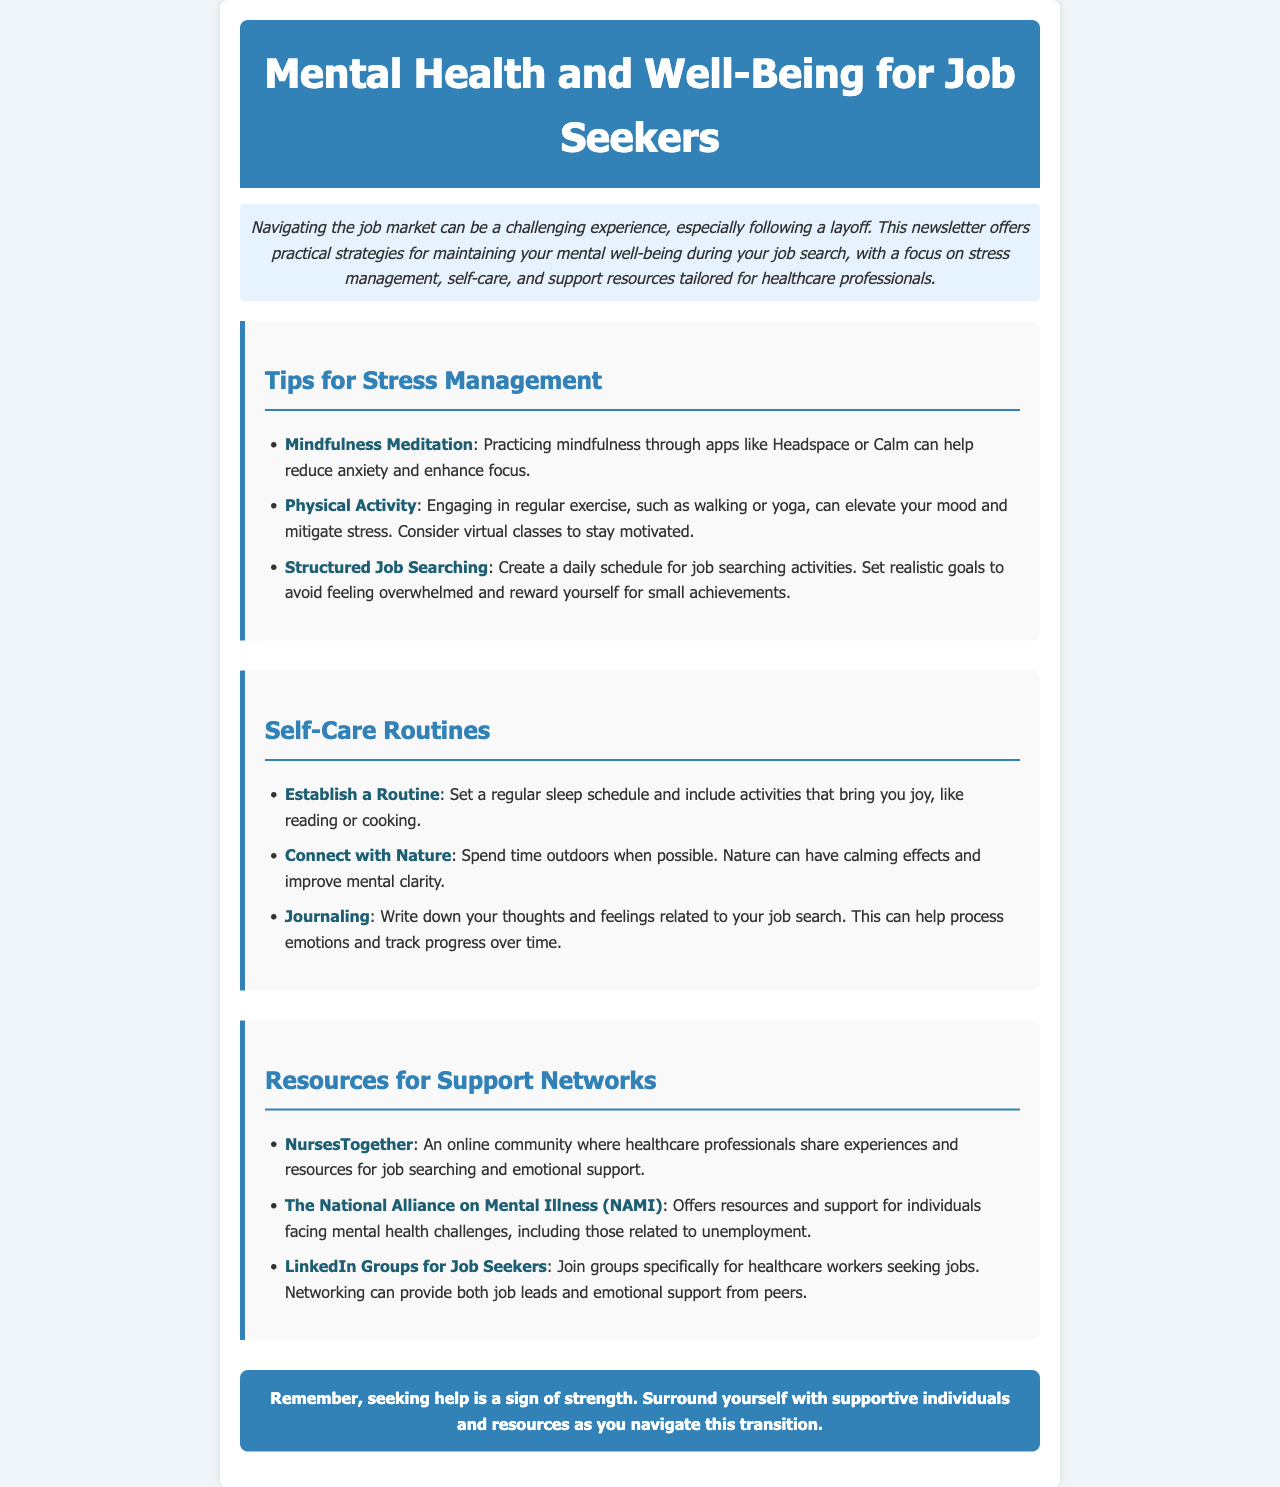what is the title of the newsletter? The title is clearly stated at the top of the document, introducing the main focus.
Answer: Mental Health and Well-Being for Job Seekers what is a recommended app for mindfulness meditation? The document mentions a couple of apps that can assist with mindfulness practices.
Answer: Headspace what activity is suggested to elevate mood and mitigate stress? The newsletter provides various activities beneficial for mental health during job searching.
Answer: Physical Activity how can job seekers connect with nature according to the newsletter? This question looks for the specific advice given for improving well-being through time spent outdoors.
Answer: Spend time outdoors what is the name of the online community for healthcare professionals? The document outlines support networks, specifically naming one designed for healthcare workers.
Answer: NursesTogether what type of writing is suggested for processing emotions? The newsletter discusses techniques for emotional management during job searching.
Answer: Journaling how can job seekers structure their job search? This question seeks advice on organizing job searching activities effectively.
Answer: Create a daily schedule what is one of the resources offered by NAMI? This question inquires about the type of support NAMI provides as described in the newsletter.
Answer: Resources and support for individuals facing mental health challenges what does the closing statement emphasize? The final message highlights an important aspect of seeking help during challenging times.
Answer: Seeking help is a sign of strength 